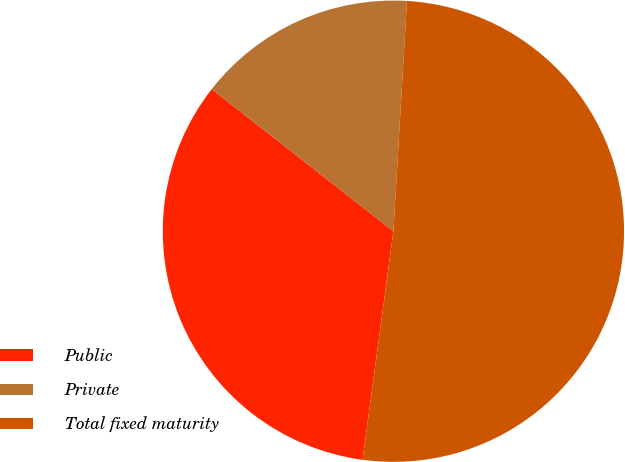Convert chart to OTSL. <chart><loc_0><loc_0><loc_500><loc_500><pie_chart><fcel>Public<fcel>Private<fcel>Total fixed maturity<nl><fcel>33.43%<fcel>15.37%<fcel>51.2%<nl></chart> 